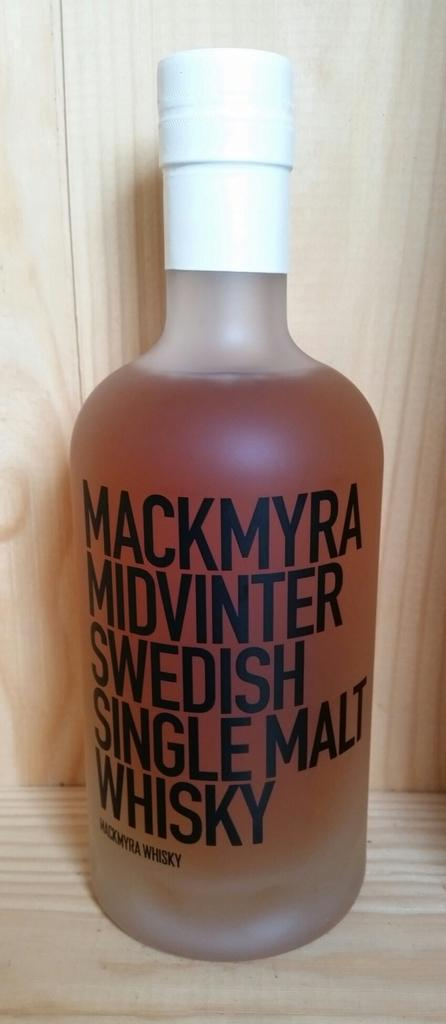<image>
Summarize the visual content of the image. A bottle of Swedish Single Malt Whisky is on display 